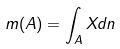Convert formula to latex. <formula><loc_0><loc_0><loc_500><loc_500>m ( A ) = \int _ { A } X d n</formula> 